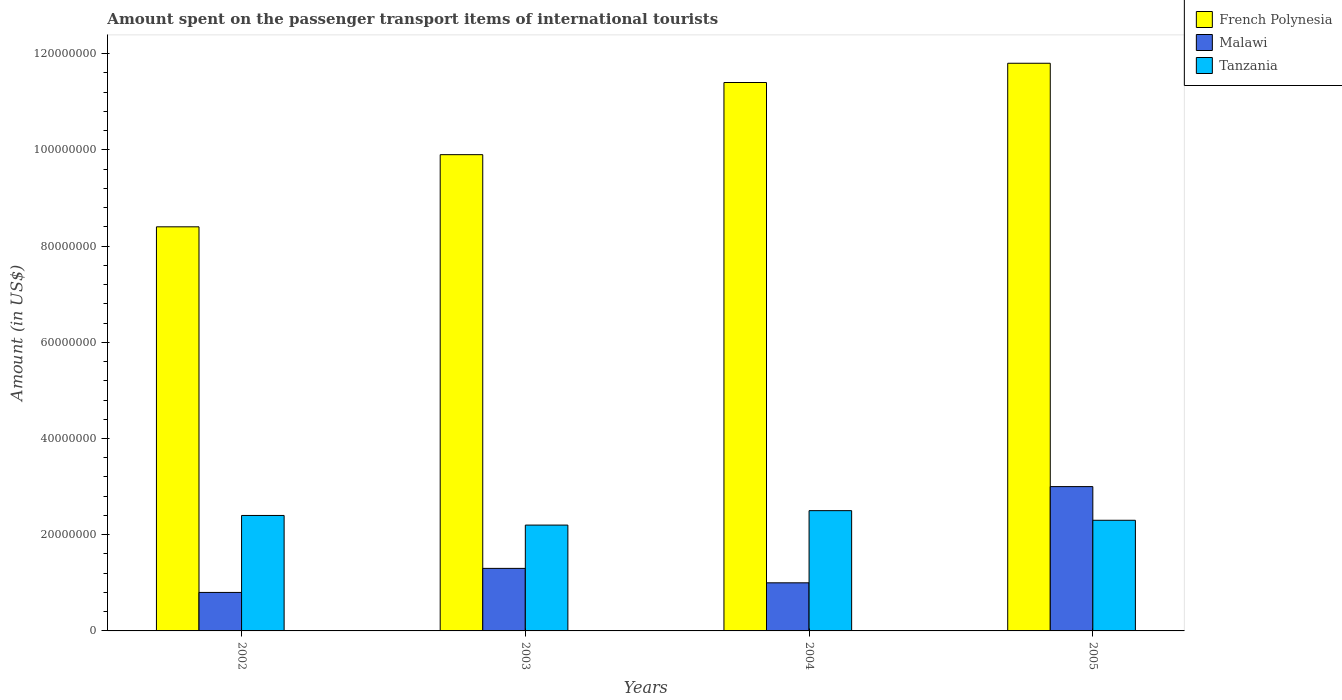How many groups of bars are there?
Ensure brevity in your answer.  4. Are the number of bars per tick equal to the number of legend labels?
Offer a terse response. Yes. Are the number of bars on each tick of the X-axis equal?
Your response must be concise. Yes. How many bars are there on the 1st tick from the left?
Keep it short and to the point. 3. In how many cases, is the number of bars for a given year not equal to the number of legend labels?
Make the answer very short. 0. What is the amount spent on the passenger transport items of international tourists in Tanzania in 2003?
Offer a terse response. 2.20e+07. Across all years, what is the maximum amount spent on the passenger transport items of international tourists in Tanzania?
Ensure brevity in your answer.  2.50e+07. In which year was the amount spent on the passenger transport items of international tourists in Malawi maximum?
Your answer should be compact. 2005. In which year was the amount spent on the passenger transport items of international tourists in Malawi minimum?
Keep it short and to the point. 2002. What is the total amount spent on the passenger transport items of international tourists in Tanzania in the graph?
Your answer should be very brief. 9.40e+07. What is the difference between the amount spent on the passenger transport items of international tourists in French Polynesia in 2002 and that in 2005?
Ensure brevity in your answer.  -3.40e+07. What is the difference between the amount spent on the passenger transport items of international tourists in Malawi in 2002 and the amount spent on the passenger transport items of international tourists in French Polynesia in 2004?
Give a very brief answer. -1.06e+08. What is the average amount spent on the passenger transport items of international tourists in French Polynesia per year?
Your answer should be very brief. 1.04e+08. In the year 2004, what is the difference between the amount spent on the passenger transport items of international tourists in Tanzania and amount spent on the passenger transport items of international tourists in Malawi?
Your answer should be very brief. 1.50e+07. In how many years, is the amount spent on the passenger transport items of international tourists in Malawi greater than 32000000 US$?
Offer a terse response. 0. What is the ratio of the amount spent on the passenger transport items of international tourists in Tanzania in 2003 to that in 2004?
Provide a succinct answer. 0.88. Is the difference between the amount spent on the passenger transport items of international tourists in Tanzania in 2003 and 2004 greater than the difference between the amount spent on the passenger transport items of international tourists in Malawi in 2003 and 2004?
Give a very brief answer. No. What does the 2nd bar from the left in 2003 represents?
Make the answer very short. Malawi. What does the 1st bar from the right in 2004 represents?
Your response must be concise. Tanzania. Is it the case that in every year, the sum of the amount spent on the passenger transport items of international tourists in French Polynesia and amount spent on the passenger transport items of international tourists in Tanzania is greater than the amount spent on the passenger transport items of international tourists in Malawi?
Make the answer very short. Yes. Are the values on the major ticks of Y-axis written in scientific E-notation?
Offer a terse response. No. Does the graph contain any zero values?
Offer a terse response. No. Does the graph contain grids?
Give a very brief answer. No. Where does the legend appear in the graph?
Your response must be concise. Top right. How are the legend labels stacked?
Give a very brief answer. Vertical. What is the title of the graph?
Make the answer very short. Amount spent on the passenger transport items of international tourists. Does "Belarus" appear as one of the legend labels in the graph?
Provide a succinct answer. No. What is the label or title of the X-axis?
Offer a terse response. Years. What is the label or title of the Y-axis?
Offer a very short reply. Amount (in US$). What is the Amount (in US$) in French Polynesia in 2002?
Provide a short and direct response. 8.40e+07. What is the Amount (in US$) in Tanzania in 2002?
Provide a succinct answer. 2.40e+07. What is the Amount (in US$) in French Polynesia in 2003?
Your response must be concise. 9.90e+07. What is the Amount (in US$) of Malawi in 2003?
Your answer should be very brief. 1.30e+07. What is the Amount (in US$) in Tanzania in 2003?
Provide a short and direct response. 2.20e+07. What is the Amount (in US$) of French Polynesia in 2004?
Ensure brevity in your answer.  1.14e+08. What is the Amount (in US$) of Tanzania in 2004?
Give a very brief answer. 2.50e+07. What is the Amount (in US$) of French Polynesia in 2005?
Ensure brevity in your answer.  1.18e+08. What is the Amount (in US$) of Malawi in 2005?
Offer a terse response. 3.00e+07. What is the Amount (in US$) in Tanzania in 2005?
Your answer should be compact. 2.30e+07. Across all years, what is the maximum Amount (in US$) of French Polynesia?
Make the answer very short. 1.18e+08. Across all years, what is the maximum Amount (in US$) of Malawi?
Your response must be concise. 3.00e+07. Across all years, what is the maximum Amount (in US$) of Tanzania?
Your answer should be very brief. 2.50e+07. Across all years, what is the minimum Amount (in US$) in French Polynesia?
Your answer should be compact. 8.40e+07. Across all years, what is the minimum Amount (in US$) of Tanzania?
Ensure brevity in your answer.  2.20e+07. What is the total Amount (in US$) of French Polynesia in the graph?
Offer a terse response. 4.15e+08. What is the total Amount (in US$) of Malawi in the graph?
Make the answer very short. 6.10e+07. What is the total Amount (in US$) of Tanzania in the graph?
Provide a succinct answer. 9.40e+07. What is the difference between the Amount (in US$) of French Polynesia in 2002 and that in 2003?
Give a very brief answer. -1.50e+07. What is the difference between the Amount (in US$) of Malawi in 2002 and that in 2003?
Keep it short and to the point. -5.00e+06. What is the difference between the Amount (in US$) of Tanzania in 2002 and that in 2003?
Provide a succinct answer. 2.00e+06. What is the difference between the Amount (in US$) of French Polynesia in 2002 and that in 2004?
Provide a short and direct response. -3.00e+07. What is the difference between the Amount (in US$) of French Polynesia in 2002 and that in 2005?
Your answer should be very brief. -3.40e+07. What is the difference between the Amount (in US$) in Malawi in 2002 and that in 2005?
Make the answer very short. -2.20e+07. What is the difference between the Amount (in US$) of French Polynesia in 2003 and that in 2004?
Offer a very short reply. -1.50e+07. What is the difference between the Amount (in US$) in Malawi in 2003 and that in 2004?
Provide a succinct answer. 3.00e+06. What is the difference between the Amount (in US$) of French Polynesia in 2003 and that in 2005?
Make the answer very short. -1.90e+07. What is the difference between the Amount (in US$) in Malawi in 2003 and that in 2005?
Provide a succinct answer. -1.70e+07. What is the difference between the Amount (in US$) of Tanzania in 2003 and that in 2005?
Offer a terse response. -1.00e+06. What is the difference between the Amount (in US$) of French Polynesia in 2004 and that in 2005?
Ensure brevity in your answer.  -4.00e+06. What is the difference between the Amount (in US$) of Malawi in 2004 and that in 2005?
Provide a short and direct response. -2.00e+07. What is the difference between the Amount (in US$) of Tanzania in 2004 and that in 2005?
Provide a short and direct response. 2.00e+06. What is the difference between the Amount (in US$) of French Polynesia in 2002 and the Amount (in US$) of Malawi in 2003?
Your response must be concise. 7.10e+07. What is the difference between the Amount (in US$) in French Polynesia in 2002 and the Amount (in US$) in Tanzania in 2003?
Your answer should be compact. 6.20e+07. What is the difference between the Amount (in US$) in Malawi in 2002 and the Amount (in US$) in Tanzania in 2003?
Offer a very short reply. -1.40e+07. What is the difference between the Amount (in US$) of French Polynesia in 2002 and the Amount (in US$) of Malawi in 2004?
Offer a terse response. 7.40e+07. What is the difference between the Amount (in US$) in French Polynesia in 2002 and the Amount (in US$) in Tanzania in 2004?
Your response must be concise. 5.90e+07. What is the difference between the Amount (in US$) of Malawi in 2002 and the Amount (in US$) of Tanzania in 2004?
Offer a very short reply. -1.70e+07. What is the difference between the Amount (in US$) of French Polynesia in 2002 and the Amount (in US$) of Malawi in 2005?
Keep it short and to the point. 5.40e+07. What is the difference between the Amount (in US$) of French Polynesia in 2002 and the Amount (in US$) of Tanzania in 2005?
Keep it short and to the point. 6.10e+07. What is the difference between the Amount (in US$) of Malawi in 2002 and the Amount (in US$) of Tanzania in 2005?
Provide a short and direct response. -1.50e+07. What is the difference between the Amount (in US$) of French Polynesia in 2003 and the Amount (in US$) of Malawi in 2004?
Your answer should be very brief. 8.90e+07. What is the difference between the Amount (in US$) in French Polynesia in 2003 and the Amount (in US$) in Tanzania in 2004?
Your answer should be very brief. 7.40e+07. What is the difference between the Amount (in US$) of Malawi in 2003 and the Amount (in US$) of Tanzania in 2004?
Make the answer very short. -1.20e+07. What is the difference between the Amount (in US$) of French Polynesia in 2003 and the Amount (in US$) of Malawi in 2005?
Your response must be concise. 6.90e+07. What is the difference between the Amount (in US$) in French Polynesia in 2003 and the Amount (in US$) in Tanzania in 2005?
Your answer should be very brief. 7.60e+07. What is the difference between the Amount (in US$) of Malawi in 2003 and the Amount (in US$) of Tanzania in 2005?
Ensure brevity in your answer.  -1.00e+07. What is the difference between the Amount (in US$) of French Polynesia in 2004 and the Amount (in US$) of Malawi in 2005?
Give a very brief answer. 8.40e+07. What is the difference between the Amount (in US$) in French Polynesia in 2004 and the Amount (in US$) in Tanzania in 2005?
Make the answer very short. 9.10e+07. What is the difference between the Amount (in US$) in Malawi in 2004 and the Amount (in US$) in Tanzania in 2005?
Give a very brief answer. -1.30e+07. What is the average Amount (in US$) in French Polynesia per year?
Ensure brevity in your answer.  1.04e+08. What is the average Amount (in US$) in Malawi per year?
Your answer should be very brief. 1.52e+07. What is the average Amount (in US$) of Tanzania per year?
Provide a succinct answer. 2.35e+07. In the year 2002, what is the difference between the Amount (in US$) in French Polynesia and Amount (in US$) in Malawi?
Provide a succinct answer. 7.60e+07. In the year 2002, what is the difference between the Amount (in US$) of French Polynesia and Amount (in US$) of Tanzania?
Provide a succinct answer. 6.00e+07. In the year 2002, what is the difference between the Amount (in US$) of Malawi and Amount (in US$) of Tanzania?
Keep it short and to the point. -1.60e+07. In the year 2003, what is the difference between the Amount (in US$) of French Polynesia and Amount (in US$) of Malawi?
Offer a terse response. 8.60e+07. In the year 2003, what is the difference between the Amount (in US$) of French Polynesia and Amount (in US$) of Tanzania?
Provide a succinct answer. 7.70e+07. In the year 2003, what is the difference between the Amount (in US$) of Malawi and Amount (in US$) of Tanzania?
Give a very brief answer. -9.00e+06. In the year 2004, what is the difference between the Amount (in US$) of French Polynesia and Amount (in US$) of Malawi?
Offer a terse response. 1.04e+08. In the year 2004, what is the difference between the Amount (in US$) of French Polynesia and Amount (in US$) of Tanzania?
Offer a terse response. 8.90e+07. In the year 2004, what is the difference between the Amount (in US$) of Malawi and Amount (in US$) of Tanzania?
Your response must be concise. -1.50e+07. In the year 2005, what is the difference between the Amount (in US$) of French Polynesia and Amount (in US$) of Malawi?
Provide a short and direct response. 8.80e+07. In the year 2005, what is the difference between the Amount (in US$) of French Polynesia and Amount (in US$) of Tanzania?
Give a very brief answer. 9.50e+07. In the year 2005, what is the difference between the Amount (in US$) in Malawi and Amount (in US$) in Tanzania?
Your answer should be very brief. 7.00e+06. What is the ratio of the Amount (in US$) in French Polynesia in 2002 to that in 2003?
Offer a terse response. 0.85. What is the ratio of the Amount (in US$) in Malawi in 2002 to that in 2003?
Give a very brief answer. 0.62. What is the ratio of the Amount (in US$) in French Polynesia in 2002 to that in 2004?
Offer a terse response. 0.74. What is the ratio of the Amount (in US$) of Malawi in 2002 to that in 2004?
Provide a succinct answer. 0.8. What is the ratio of the Amount (in US$) in French Polynesia in 2002 to that in 2005?
Your answer should be compact. 0.71. What is the ratio of the Amount (in US$) in Malawi in 2002 to that in 2005?
Offer a very short reply. 0.27. What is the ratio of the Amount (in US$) in Tanzania in 2002 to that in 2005?
Your answer should be compact. 1.04. What is the ratio of the Amount (in US$) in French Polynesia in 2003 to that in 2004?
Make the answer very short. 0.87. What is the ratio of the Amount (in US$) of Malawi in 2003 to that in 2004?
Keep it short and to the point. 1.3. What is the ratio of the Amount (in US$) in French Polynesia in 2003 to that in 2005?
Your response must be concise. 0.84. What is the ratio of the Amount (in US$) of Malawi in 2003 to that in 2005?
Your answer should be compact. 0.43. What is the ratio of the Amount (in US$) in Tanzania in 2003 to that in 2005?
Give a very brief answer. 0.96. What is the ratio of the Amount (in US$) of French Polynesia in 2004 to that in 2005?
Ensure brevity in your answer.  0.97. What is the ratio of the Amount (in US$) of Malawi in 2004 to that in 2005?
Offer a terse response. 0.33. What is the ratio of the Amount (in US$) of Tanzania in 2004 to that in 2005?
Offer a very short reply. 1.09. What is the difference between the highest and the second highest Amount (in US$) of Malawi?
Your answer should be very brief. 1.70e+07. What is the difference between the highest and the second highest Amount (in US$) in Tanzania?
Offer a terse response. 1.00e+06. What is the difference between the highest and the lowest Amount (in US$) in French Polynesia?
Make the answer very short. 3.40e+07. What is the difference between the highest and the lowest Amount (in US$) in Malawi?
Your answer should be compact. 2.20e+07. 